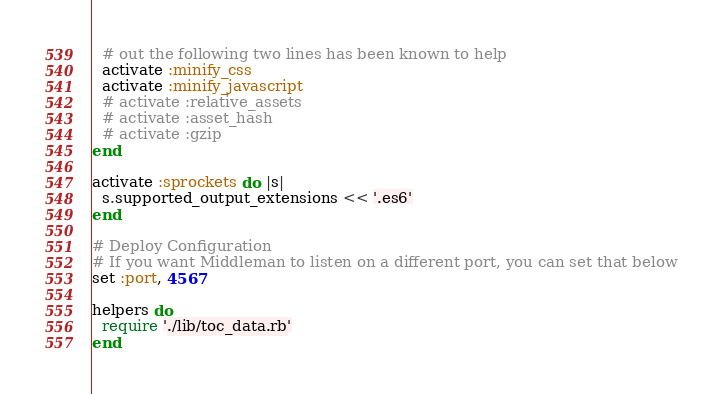<code> <loc_0><loc_0><loc_500><loc_500><_Ruby_>  # out the following two lines has been known to help
  activate :minify_css
  activate :minify_javascript
  # activate :relative_assets
  # activate :asset_hash
  # activate :gzip
end

activate :sprockets do |s|
  s.supported_output_extensions << '.es6'
end

# Deploy Configuration
# If you want Middleman to listen on a different port, you can set that below
set :port, 4567

helpers do
  require './lib/toc_data.rb'
end
</code> 